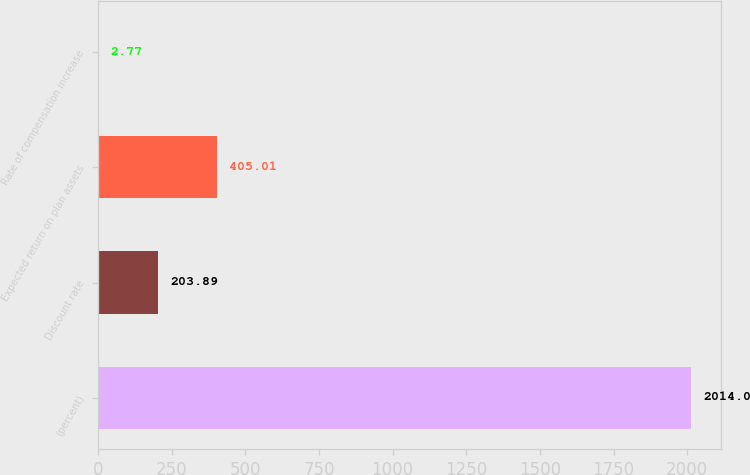Convert chart to OTSL. <chart><loc_0><loc_0><loc_500><loc_500><bar_chart><fcel>(percent)<fcel>Discount rate<fcel>Expected return on plan assets<fcel>Rate of compensation increase<nl><fcel>2014<fcel>203.89<fcel>405.01<fcel>2.77<nl></chart> 